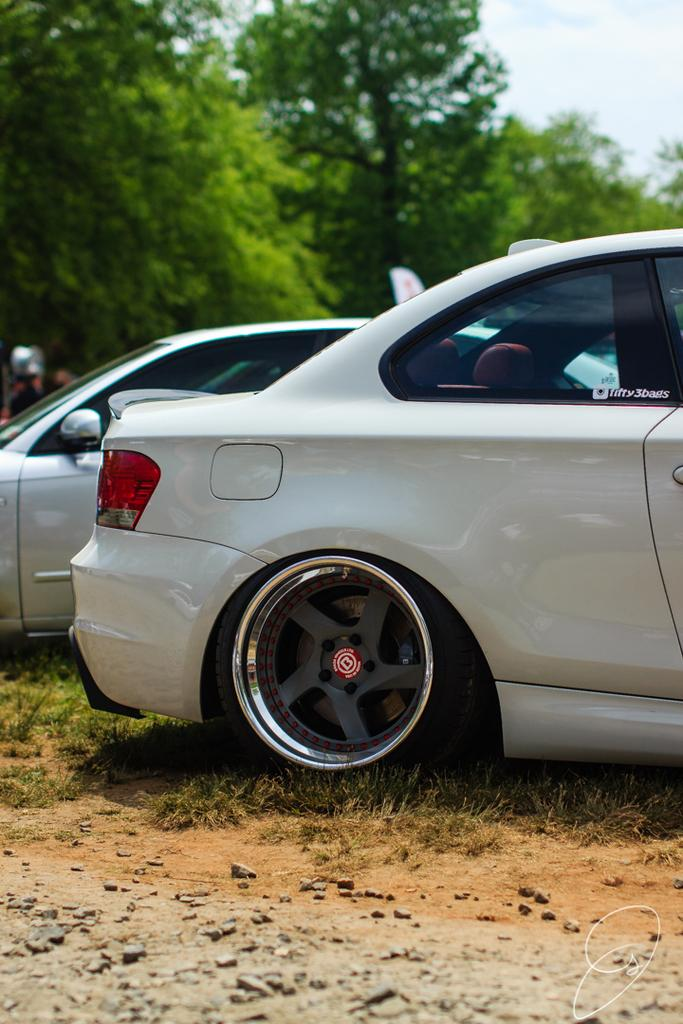What types of objects are on the ground in the image? There are vehicles on the ground in the image. What type of natural elements can be seen in the image? Stones, grass, trees, and the sky are visible in the image. Can you describe the person in the background of the image? There is a person in the background of the image, but no specific details about the person are provided. What is the natural setting visible in the image? The natural setting includes grass, trees, and the sky. What type of boot is the person wearing in the image? There is no person wearing a boot in the image; the person's attire is not described. What degree of education does the person in the image have? There is no information about the person's education in the image. 